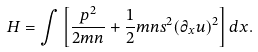Convert formula to latex. <formula><loc_0><loc_0><loc_500><loc_500>H = \int \left [ \frac { p ^ { 2 } } { 2 m n } + \frac { 1 } { 2 } m n s ^ { 2 } ( \partial _ { x } u ) ^ { 2 } \right ] d x .</formula> 